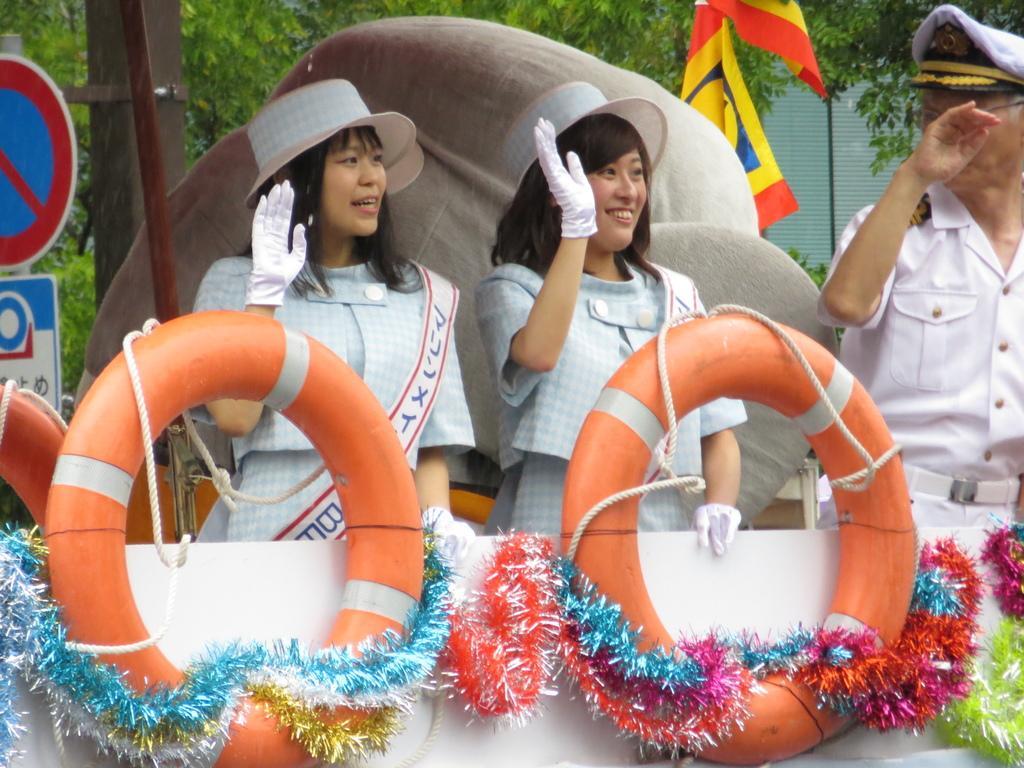In one or two sentences, can you explain what this image depicts? In this image I can see three people with white and blue color dresses. I can see one person with the cap and two people with the hats. In-front of these people there are orange color tubes and I can see the decorative items and ropes to it. In the back there are boards, flags and also trees can be seen. 